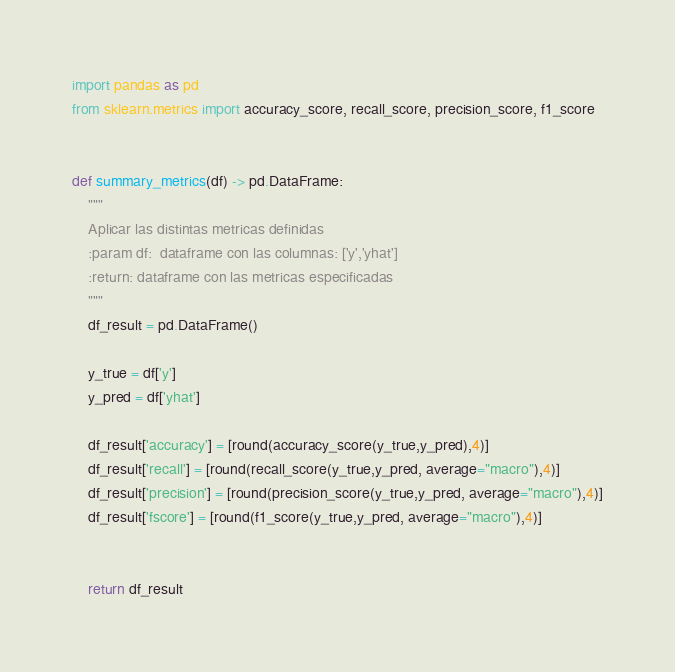Convert code to text. <code><loc_0><loc_0><loc_500><loc_500><_Python_>import pandas as pd
from sklearn.metrics import accuracy_score, recall_score, precision_score, f1_score


def summary_metrics(df) -> pd.DataFrame:
    """
    Aplicar las distintas metricas definidas
    :param df:  dataframe con las columnas: ['y','yhat']
    :return: dataframe con las metricas especificadas
    """
    df_result = pd.DataFrame()

    y_true = df['y']
    y_pred = df['yhat']

    df_result['accuracy'] = [round(accuracy_score(y_true,y_pred),4)]
    df_result['recall'] = [round(recall_score(y_true,y_pred, average="macro"),4)]
    df_result['precision'] = [round(precision_score(y_true,y_pred, average="macro"),4)]
    df_result['fscore'] = [round(f1_score(y_true,y_pred, average="macro"),4)]


    return df_result</code> 